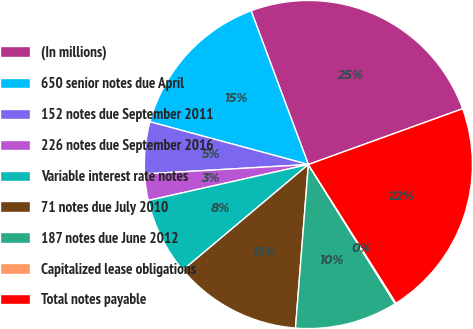Convert chart. <chart><loc_0><loc_0><loc_500><loc_500><pie_chart><fcel>(In millions)<fcel>650 senior notes due April<fcel>152 notes due September 2011<fcel>226 notes due September 2016<fcel>Variable interest rate notes<fcel>71 notes due July 2010<fcel>187 notes due June 2012<fcel>Capitalized lease obligations<fcel>Total notes payable<nl><fcel>25.15%<fcel>15.13%<fcel>5.11%<fcel>2.6%<fcel>7.61%<fcel>12.62%<fcel>10.12%<fcel>0.1%<fcel>21.55%<nl></chart> 